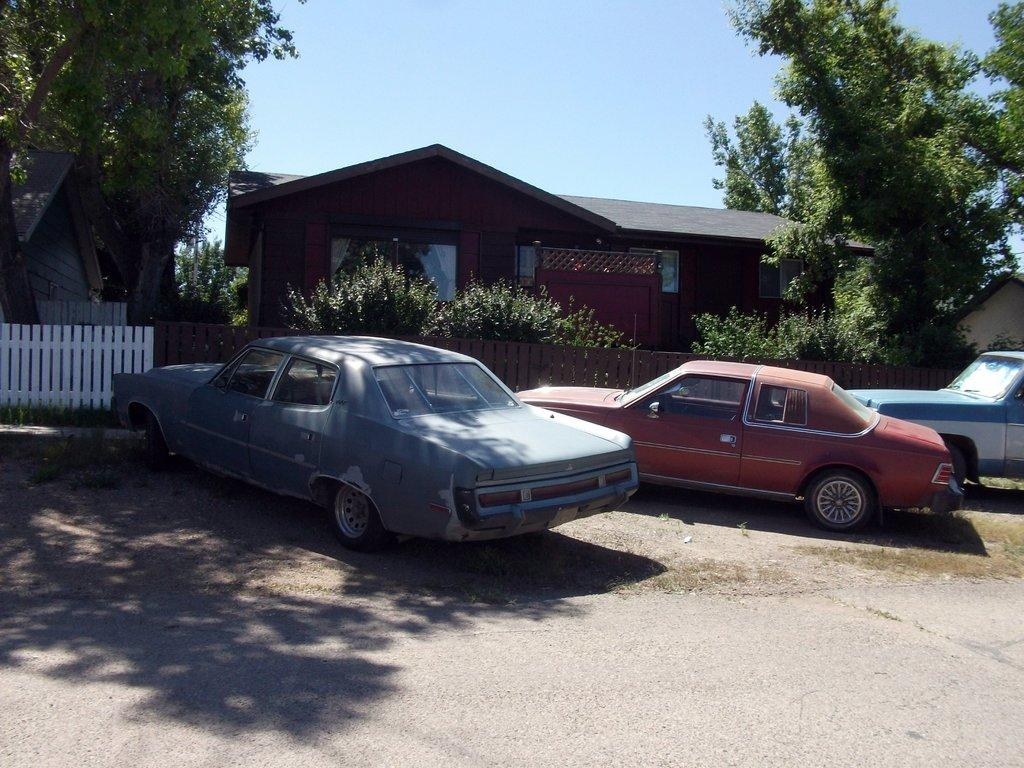What types of objects can be seen in the image? There are vehicles, a road, houses, plants, fencing, and trees in the image. Can you describe the setting of the image? The image features a road, houses, plants, fencing, and trees, which suggests it is a residential area. What is visible in the background of the image? The sky is visible in the background of the image. What type of vegetation is present in the image? There are plants and trees in the image. What type of legal advice is the company providing in the image? There is no mention of a company or legal advice in the image; it features vehicles, a road, houses, plants, fencing, trees, and the sky. 